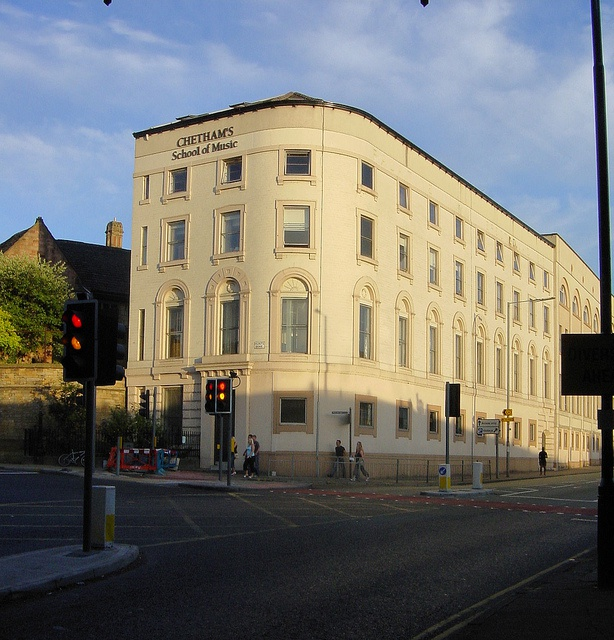Describe the objects in this image and their specific colors. I can see traffic light in gray, black, red, brown, and maroon tones, traffic light in gray, black, and tan tones, traffic light in gray, black, and maroon tones, traffic light in gray, black, and purple tones, and people in gray and black tones in this image. 